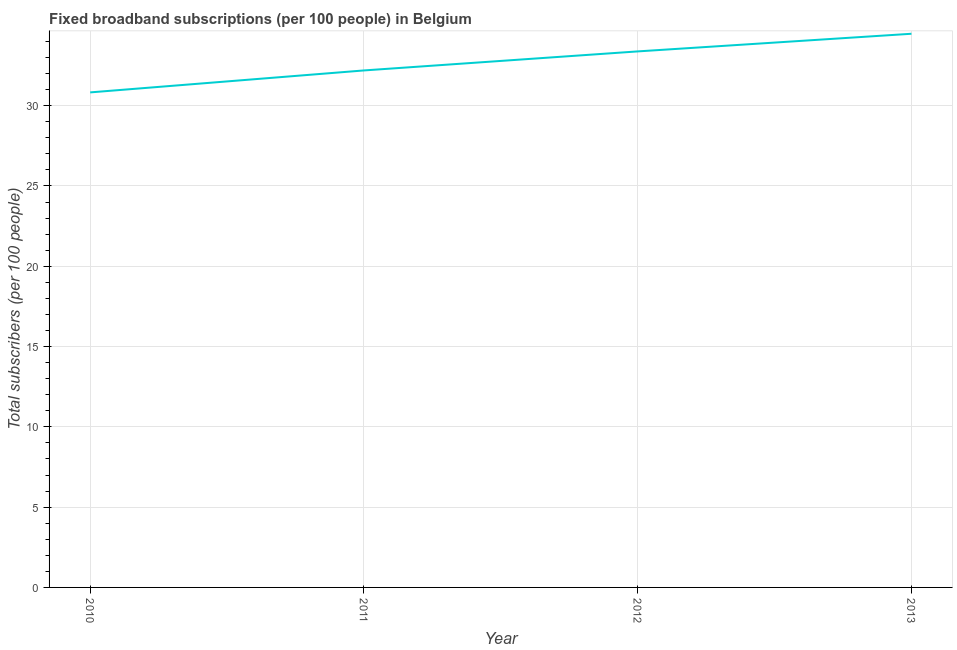What is the total number of fixed broadband subscriptions in 2012?
Make the answer very short. 33.38. Across all years, what is the maximum total number of fixed broadband subscriptions?
Provide a short and direct response. 34.48. Across all years, what is the minimum total number of fixed broadband subscriptions?
Make the answer very short. 30.83. In which year was the total number of fixed broadband subscriptions minimum?
Offer a very short reply. 2010. What is the sum of the total number of fixed broadband subscriptions?
Ensure brevity in your answer.  130.89. What is the difference between the total number of fixed broadband subscriptions in 2010 and 2011?
Provide a short and direct response. -1.37. What is the average total number of fixed broadband subscriptions per year?
Your answer should be compact. 32.72. What is the median total number of fixed broadband subscriptions?
Make the answer very short. 32.79. In how many years, is the total number of fixed broadband subscriptions greater than 14 ?
Provide a succinct answer. 4. Do a majority of the years between 2013 and 2010 (inclusive) have total number of fixed broadband subscriptions greater than 10 ?
Give a very brief answer. Yes. What is the ratio of the total number of fixed broadband subscriptions in 2010 to that in 2012?
Your answer should be very brief. 0.92. Is the total number of fixed broadband subscriptions in 2010 less than that in 2011?
Keep it short and to the point. Yes. What is the difference between the highest and the second highest total number of fixed broadband subscriptions?
Ensure brevity in your answer.  1.1. Is the sum of the total number of fixed broadband subscriptions in 2011 and 2012 greater than the maximum total number of fixed broadband subscriptions across all years?
Offer a terse response. Yes. What is the difference between the highest and the lowest total number of fixed broadband subscriptions?
Provide a succinct answer. 3.65. Does the total number of fixed broadband subscriptions monotonically increase over the years?
Ensure brevity in your answer.  Yes. Does the graph contain grids?
Provide a succinct answer. Yes. What is the title of the graph?
Provide a succinct answer. Fixed broadband subscriptions (per 100 people) in Belgium. What is the label or title of the X-axis?
Provide a short and direct response. Year. What is the label or title of the Y-axis?
Offer a very short reply. Total subscribers (per 100 people). What is the Total subscribers (per 100 people) of 2010?
Provide a succinct answer. 30.83. What is the Total subscribers (per 100 people) of 2011?
Ensure brevity in your answer.  32.2. What is the Total subscribers (per 100 people) of 2012?
Provide a short and direct response. 33.38. What is the Total subscribers (per 100 people) of 2013?
Offer a very short reply. 34.48. What is the difference between the Total subscribers (per 100 people) in 2010 and 2011?
Offer a very short reply. -1.37. What is the difference between the Total subscribers (per 100 people) in 2010 and 2012?
Your answer should be compact. -2.55. What is the difference between the Total subscribers (per 100 people) in 2010 and 2013?
Ensure brevity in your answer.  -3.65. What is the difference between the Total subscribers (per 100 people) in 2011 and 2012?
Make the answer very short. -1.18. What is the difference between the Total subscribers (per 100 people) in 2011 and 2013?
Offer a terse response. -2.28. What is the difference between the Total subscribers (per 100 people) in 2012 and 2013?
Make the answer very short. -1.1. What is the ratio of the Total subscribers (per 100 people) in 2010 to that in 2011?
Offer a very short reply. 0.96. What is the ratio of the Total subscribers (per 100 people) in 2010 to that in 2012?
Give a very brief answer. 0.92. What is the ratio of the Total subscribers (per 100 people) in 2010 to that in 2013?
Your answer should be very brief. 0.89. What is the ratio of the Total subscribers (per 100 people) in 2011 to that in 2012?
Your response must be concise. 0.96. What is the ratio of the Total subscribers (per 100 people) in 2011 to that in 2013?
Your answer should be very brief. 0.93. What is the ratio of the Total subscribers (per 100 people) in 2012 to that in 2013?
Your response must be concise. 0.97. 